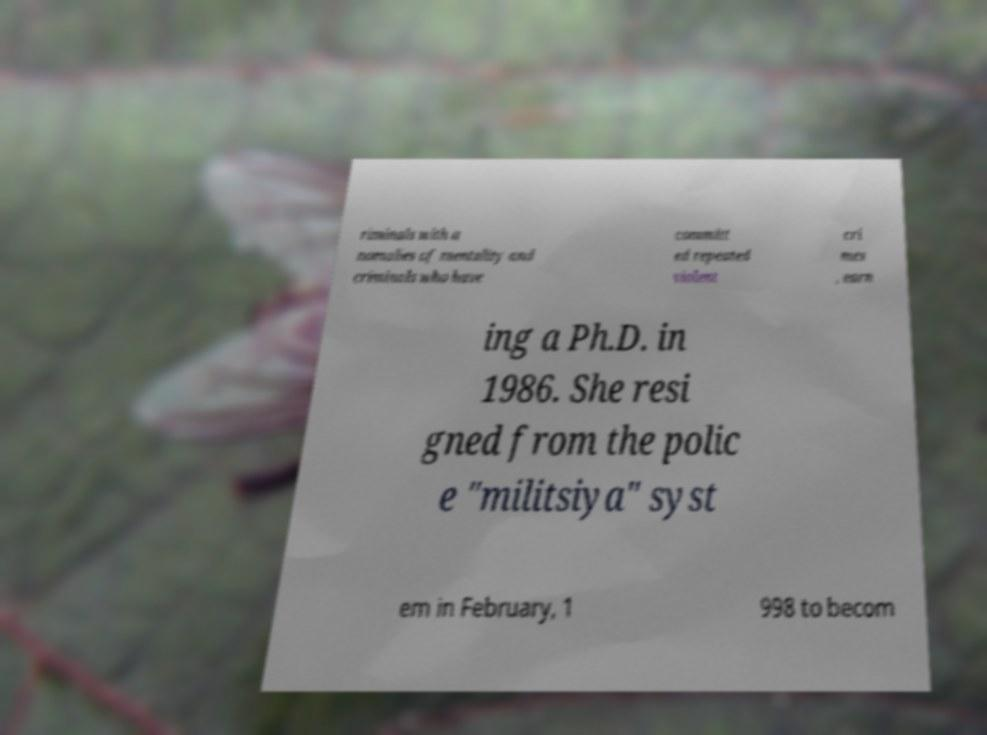Please identify and transcribe the text found in this image. riminals with a nomalies of mentality and criminals who have committ ed repeated violent cri mes , earn ing a Ph.D. in 1986. She resi gned from the polic e "militsiya" syst em in February, 1 998 to becom 